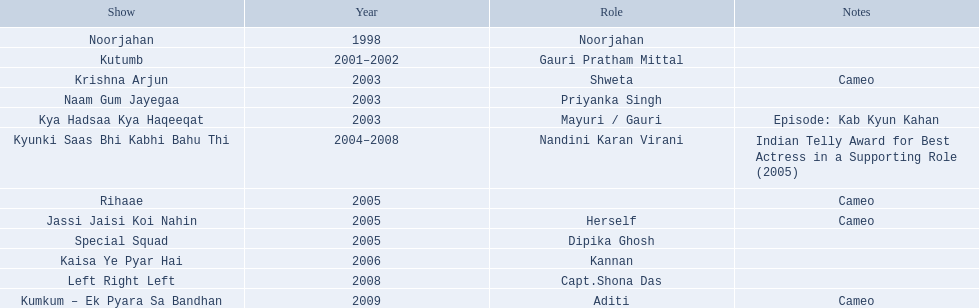What shows has gauri pradhan tejwani been in? Noorjahan, Kutumb, Krishna Arjun, Naam Gum Jayegaa, Kya Hadsaa Kya Haqeeqat, Kyunki Saas Bhi Kabhi Bahu Thi, Rihaae, Jassi Jaisi Koi Nahin, Special Squad, Kaisa Ye Pyar Hai, Left Right Left, Kumkum – Ek Pyara Sa Bandhan. Of these shows, which one lasted for more than a year? Kutumb, Kyunki Saas Bhi Kabhi Bahu Thi. Could you help me parse every detail presented in this table? {'header': ['Show', 'Year', 'Role', 'Notes'], 'rows': [['Noorjahan', '1998', 'Noorjahan', ''], ['Kutumb', '2001–2002', 'Gauri Pratham Mittal', ''], ['Krishna Arjun', '2003', 'Shweta', 'Cameo'], ['Naam Gum Jayegaa', '2003', 'Priyanka Singh', ''], ['Kya Hadsaa Kya Haqeeqat', '2003', 'Mayuri / Gauri', 'Episode: Kab Kyun Kahan'], ['Kyunki Saas Bhi Kabhi Bahu Thi', '2004–2008', 'Nandini Karan Virani', 'Indian Telly Award for Best Actress in a Supporting Role (2005)'], ['Rihaae', '2005', '', 'Cameo'], ['Jassi Jaisi Koi Nahin', '2005', 'Herself', 'Cameo'], ['Special Squad', '2005', 'Dipika Ghosh', ''], ['Kaisa Ye Pyar Hai', '2006', 'Kannan', ''], ['Left Right Left', '2008', 'Capt.Shona Das', ''], ['Kumkum – Ek Pyara Sa Bandhan', '2009', 'Aditi', 'Cameo']]} Which of these lasted the longest? Kyunki Saas Bhi Kabhi Bahu Thi. 